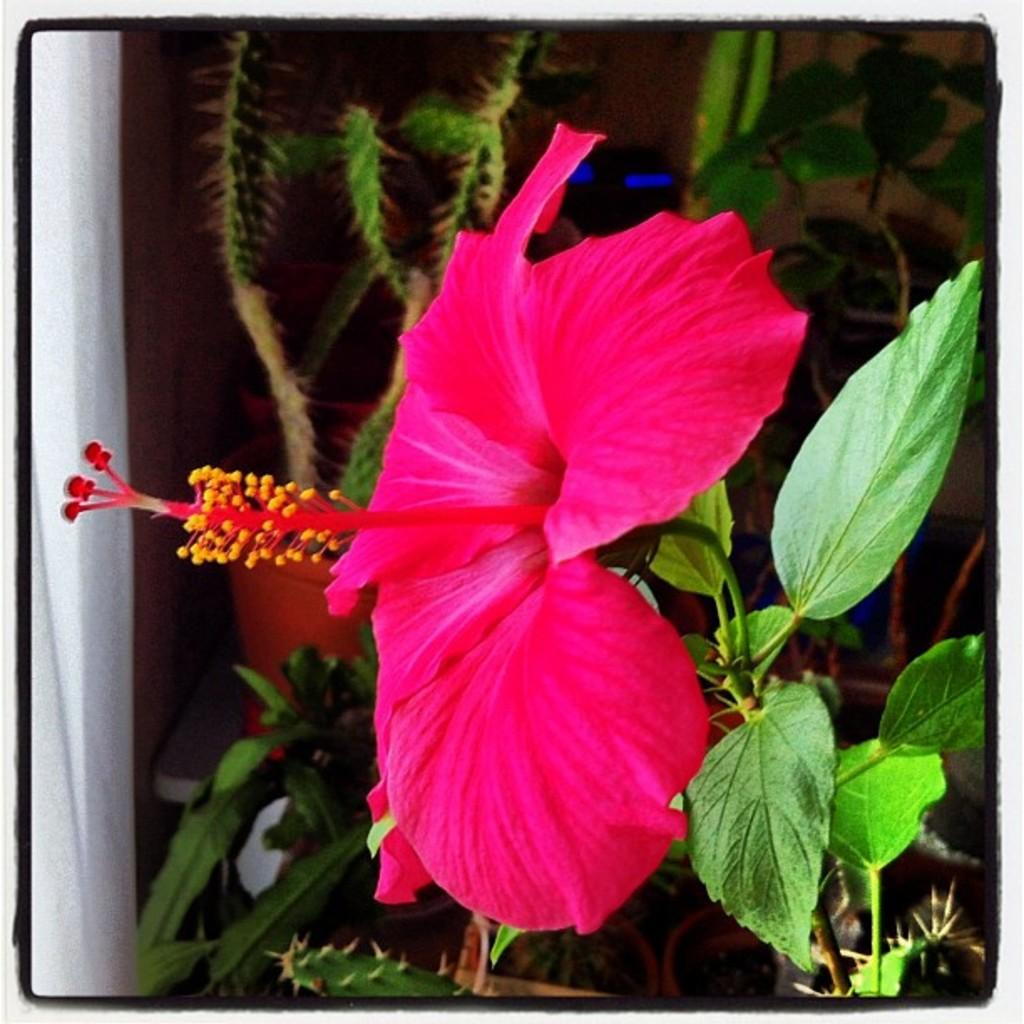What is present in the image? There is a plant in the image. What specific feature can be observed on the plant? The plant has a flower. What is the color of the flower? The flower is pink in color. Can you describe the background of the image? There are more plants visible in the background of the image. What type of string is being used to hold the flower in place in the image? There is no string present in the image; the flower is naturally attached to the plant. 